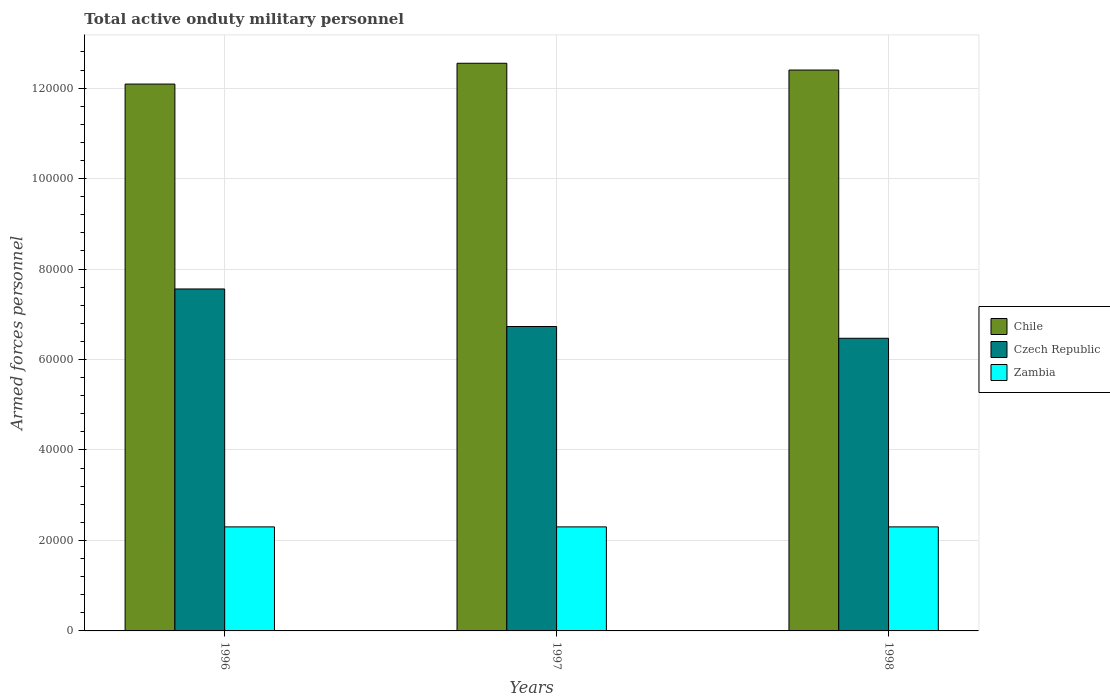Are the number of bars per tick equal to the number of legend labels?
Keep it short and to the point. Yes. How many bars are there on the 2nd tick from the left?
Provide a succinct answer. 3. In how many cases, is the number of bars for a given year not equal to the number of legend labels?
Give a very brief answer. 0. What is the number of armed forces personnel in Chile in 1998?
Your answer should be compact. 1.24e+05. Across all years, what is the maximum number of armed forces personnel in Zambia?
Provide a short and direct response. 2.30e+04. Across all years, what is the minimum number of armed forces personnel in Zambia?
Provide a short and direct response. 2.30e+04. What is the total number of armed forces personnel in Czech Republic in the graph?
Make the answer very short. 2.08e+05. What is the difference between the number of armed forces personnel in Chile in 1997 and that in 1998?
Provide a succinct answer. 1500. What is the difference between the number of armed forces personnel in Chile in 1998 and the number of armed forces personnel in Zambia in 1996?
Your answer should be very brief. 1.01e+05. What is the average number of armed forces personnel in Czech Republic per year?
Your answer should be compact. 6.92e+04. In the year 1998, what is the difference between the number of armed forces personnel in Zambia and number of armed forces personnel in Czech Republic?
Make the answer very short. -4.17e+04. In how many years, is the number of armed forces personnel in Czech Republic greater than 4000?
Offer a very short reply. 3. What is the ratio of the number of armed forces personnel in Czech Republic in 1997 to that in 1998?
Make the answer very short. 1.04. Is the difference between the number of armed forces personnel in Zambia in 1996 and 1998 greater than the difference between the number of armed forces personnel in Czech Republic in 1996 and 1998?
Your response must be concise. No. What is the difference between the highest and the second highest number of armed forces personnel in Chile?
Give a very brief answer. 1500. What is the difference between the highest and the lowest number of armed forces personnel in Chile?
Make the answer very short. 4600. What does the 2nd bar from the left in 1998 represents?
Provide a succinct answer. Czech Republic. What does the 2nd bar from the right in 1998 represents?
Your response must be concise. Czech Republic. Is it the case that in every year, the sum of the number of armed forces personnel in Zambia and number of armed forces personnel in Chile is greater than the number of armed forces personnel in Czech Republic?
Offer a terse response. Yes. How many bars are there?
Provide a short and direct response. 9. Are all the bars in the graph horizontal?
Make the answer very short. No. What is the difference between two consecutive major ticks on the Y-axis?
Offer a terse response. 2.00e+04. Are the values on the major ticks of Y-axis written in scientific E-notation?
Your answer should be compact. No. Where does the legend appear in the graph?
Ensure brevity in your answer.  Center right. How are the legend labels stacked?
Your answer should be compact. Vertical. What is the title of the graph?
Your answer should be compact. Total active onduty military personnel. What is the label or title of the Y-axis?
Keep it short and to the point. Armed forces personnel. What is the Armed forces personnel in Chile in 1996?
Your answer should be very brief. 1.21e+05. What is the Armed forces personnel of Czech Republic in 1996?
Your answer should be compact. 7.56e+04. What is the Armed forces personnel in Zambia in 1996?
Give a very brief answer. 2.30e+04. What is the Armed forces personnel in Chile in 1997?
Provide a succinct answer. 1.26e+05. What is the Armed forces personnel of Czech Republic in 1997?
Your response must be concise. 6.73e+04. What is the Armed forces personnel of Zambia in 1997?
Provide a succinct answer. 2.30e+04. What is the Armed forces personnel of Chile in 1998?
Provide a short and direct response. 1.24e+05. What is the Armed forces personnel of Czech Republic in 1998?
Provide a short and direct response. 6.47e+04. What is the Armed forces personnel of Zambia in 1998?
Make the answer very short. 2.30e+04. Across all years, what is the maximum Armed forces personnel in Chile?
Ensure brevity in your answer.  1.26e+05. Across all years, what is the maximum Armed forces personnel in Czech Republic?
Keep it short and to the point. 7.56e+04. Across all years, what is the maximum Armed forces personnel of Zambia?
Keep it short and to the point. 2.30e+04. Across all years, what is the minimum Armed forces personnel in Chile?
Make the answer very short. 1.21e+05. Across all years, what is the minimum Armed forces personnel in Czech Republic?
Offer a very short reply. 6.47e+04. Across all years, what is the minimum Armed forces personnel of Zambia?
Provide a short and direct response. 2.30e+04. What is the total Armed forces personnel of Chile in the graph?
Offer a terse response. 3.70e+05. What is the total Armed forces personnel of Czech Republic in the graph?
Your response must be concise. 2.08e+05. What is the total Armed forces personnel in Zambia in the graph?
Ensure brevity in your answer.  6.90e+04. What is the difference between the Armed forces personnel of Chile in 1996 and that in 1997?
Your answer should be compact. -4600. What is the difference between the Armed forces personnel in Czech Republic in 1996 and that in 1997?
Ensure brevity in your answer.  8300. What is the difference between the Armed forces personnel of Chile in 1996 and that in 1998?
Keep it short and to the point. -3100. What is the difference between the Armed forces personnel in Czech Republic in 1996 and that in 1998?
Make the answer very short. 1.09e+04. What is the difference between the Armed forces personnel in Zambia in 1996 and that in 1998?
Ensure brevity in your answer.  0. What is the difference between the Armed forces personnel in Chile in 1997 and that in 1998?
Offer a terse response. 1500. What is the difference between the Armed forces personnel in Czech Republic in 1997 and that in 1998?
Your response must be concise. 2600. What is the difference between the Armed forces personnel in Zambia in 1997 and that in 1998?
Keep it short and to the point. 0. What is the difference between the Armed forces personnel in Chile in 1996 and the Armed forces personnel in Czech Republic in 1997?
Ensure brevity in your answer.  5.36e+04. What is the difference between the Armed forces personnel in Chile in 1996 and the Armed forces personnel in Zambia in 1997?
Your answer should be very brief. 9.79e+04. What is the difference between the Armed forces personnel of Czech Republic in 1996 and the Armed forces personnel of Zambia in 1997?
Ensure brevity in your answer.  5.26e+04. What is the difference between the Armed forces personnel in Chile in 1996 and the Armed forces personnel in Czech Republic in 1998?
Make the answer very short. 5.62e+04. What is the difference between the Armed forces personnel in Chile in 1996 and the Armed forces personnel in Zambia in 1998?
Make the answer very short. 9.79e+04. What is the difference between the Armed forces personnel of Czech Republic in 1996 and the Armed forces personnel of Zambia in 1998?
Provide a short and direct response. 5.26e+04. What is the difference between the Armed forces personnel in Chile in 1997 and the Armed forces personnel in Czech Republic in 1998?
Keep it short and to the point. 6.08e+04. What is the difference between the Armed forces personnel of Chile in 1997 and the Armed forces personnel of Zambia in 1998?
Keep it short and to the point. 1.02e+05. What is the difference between the Armed forces personnel in Czech Republic in 1997 and the Armed forces personnel in Zambia in 1998?
Ensure brevity in your answer.  4.43e+04. What is the average Armed forces personnel of Chile per year?
Offer a very short reply. 1.23e+05. What is the average Armed forces personnel of Czech Republic per year?
Offer a terse response. 6.92e+04. What is the average Armed forces personnel of Zambia per year?
Provide a short and direct response. 2.30e+04. In the year 1996, what is the difference between the Armed forces personnel of Chile and Armed forces personnel of Czech Republic?
Ensure brevity in your answer.  4.53e+04. In the year 1996, what is the difference between the Armed forces personnel of Chile and Armed forces personnel of Zambia?
Offer a terse response. 9.79e+04. In the year 1996, what is the difference between the Armed forces personnel of Czech Republic and Armed forces personnel of Zambia?
Provide a succinct answer. 5.26e+04. In the year 1997, what is the difference between the Armed forces personnel in Chile and Armed forces personnel in Czech Republic?
Your answer should be very brief. 5.82e+04. In the year 1997, what is the difference between the Armed forces personnel in Chile and Armed forces personnel in Zambia?
Offer a very short reply. 1.02e+05. In the year 1997, what is the difference between the Armed forces personnel in Czech Republic and Armed forces personnel in Zambia?
Provide a succinct answer. 4.43e+04. In the year 1998, what is the difference between the Armed forces personnel in Chile and Armed forces personnel in Czech Republic?
Make the answer very short. 5.93e+04. In the year 1998, what is the difference between the Armed forces personnel of Chile and Armed forces personnel of Zambia?
Make the answer very short. 1.01e+05. In the year 1998, what is the difference between the Armed forces personnel of Czech Republic and Armed forces personnel of Zambia?
Give a very brief answer. 4.17e+04. What is the ratio of the Armed forces personnel in Chile in 1996 to that in 1997?
Provide a short and direct response. 0.96. What is the ratio of the Armed forces personnel of Czech Republic in 1996 to that in 1997?
Provide a succinct answer. 1.12. What is the ratio of the Armed forces personnel of Czech Republic in 1996 to that in 1998?
Ensure brevity in your answer.  1.17. What is the ratio of the Armed forces personnel in Zambia in 1996 to that in 1998?
Offer a terse response. 1. What is the ratio of the Armed forces personnel in Chile in 1997 to that in 1998?
Your answer should be very brief. 1.01. What is the ratio of the Armed forces personnel of Czech Republic in 1997 to that in 1998?
Offer a terse response. 1.04. What is the difference between the highest and the second highest Armed forces personnel in Chile?
Offer a terse response. 1500. What is the difference between the highest and the second highest Armed forces personnel in Czech Republic?
Your response must be concise. 8300. What is the difference between the highest and the lowest Armed forces personnel in Chile?
Your response must be concise. 4600. What is the difference between the highest and the lowest Armed forces personnel in Czech Republic?
Provide a succinct answer. 1.09e+04. What is the difference between the highest and the lowest Armed forces personnel in Zambia?
Ensure brevity in your answer.  0. 